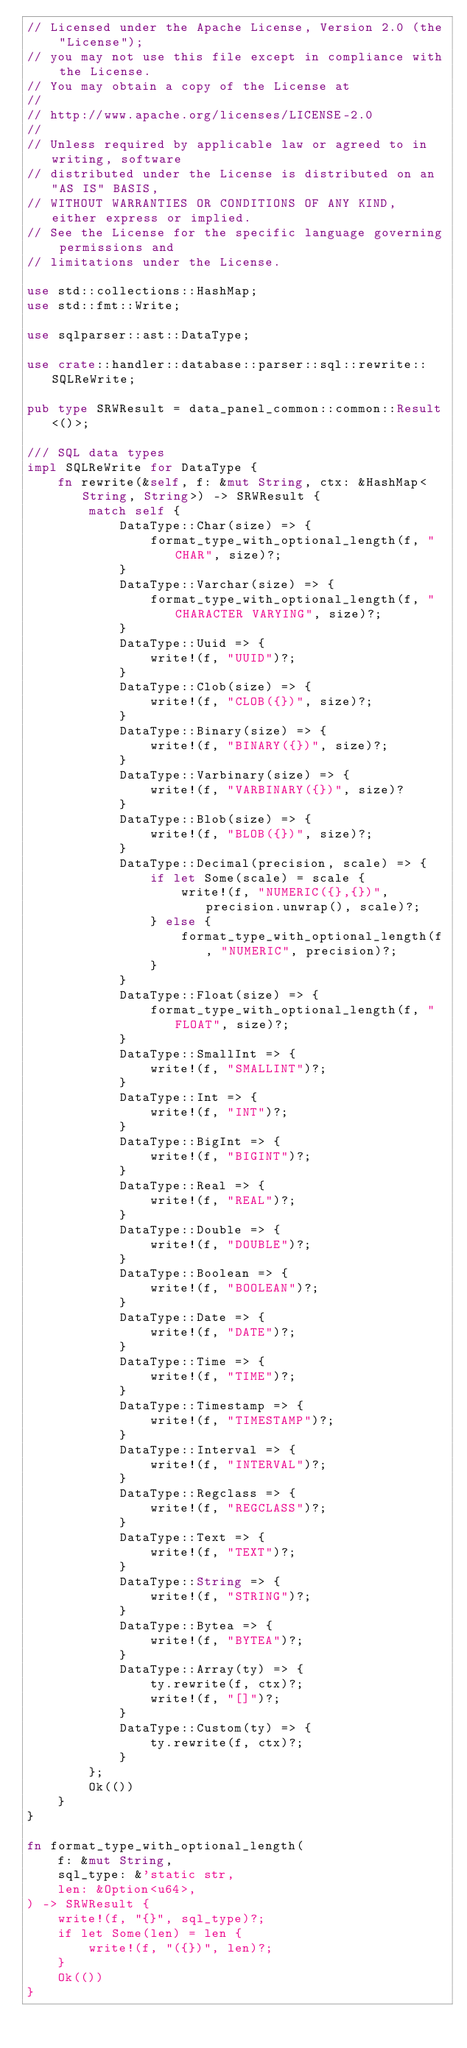<code> <loc_0><loc_0><loc_500><loc_500><_Rust_>// Licensed under the Apache License, Version 2.0 (the "License");
// you may not use this file except in compliance with the License.
// You may obtain a copy of the License at
//
// http://www.apache.org/licenses/LICENSE-2.0
//
// Unless required by applicable law or agreed to in writing, software
// distributed under the License is distributed on an "AS IS" BASIS,
// WITHOUT WARRANTIES OR CONDITIONS OF ANY KIND, either express or implied.
// See the License for the specific language governing permissions and
// limitations under the License.

use std::collections::HashMap;
use std::fmt::Write;

use sqlparser::ast::DataType;

use crate::handler::database::parser::sql::rewrite::SQLReWrite;

pub type SRWResult = data_panel_common::common::Result<()>;

/// SQL data types
impl SQLReWrite for DataType {
    fn rewrite(&self, f: &mut String, ctx: &HashMap<String, String>) -> SRWResult {
        match self {
            DataType::Char(size) => {
                format_type_with_optional_length(f, "CHAR", size)?;
            }
            DataType::Varchar(size) => {
                format_type_with_optional_length(f, "CHARACTER VARYING", size)?;
            }
            DataType::Uuid => {
                write!(f, "UUID")?;
            }
            DataType::Clob(size) => {
                write!(f, "CLOB({})", size)?;
            }
            DataType::Binary(size) => {
                write!(f, "BINARY({})", size)?;
            }
            DataType::Varbinary(size) => {
                write!(f, "VARBINARY({})", size)?
            }
            DataType::Blob(size) => {
                write!(f, "BLOB({})", size)?;
            }
            DataType::Decimal(precision, scale) => {
                if let Some(scale) = scale {
                    write!(f, "NUMERIC({},{})", precision.unwrap(), scale)?;
                } else {
                    format_type_with_optional_length(f, "NUMERIC", precision)?;
                }
            }
            DataType::Float(size) => {
                format_type_with_optional_length(f, "FLOAT", size)?;
            }
            DataType::SmallInt => {
                write!(f, "SMALLINT")?;
            }
            DataType::Int => {
                write!(f, "INT")?;
            }
            DataType::BigInt => {
                write!(f, "BIGINT")?;
            }
            DataType::Real => {
                write!(f, "REAL")?;
            }
            DataType::Double => {
                write!(f, "DOUBLE")?;
            }
            DataType::Boolean => {
                write!(f, "BOOLEAN")?;
            }
            DataType::Date => {
                write!(f, "DATE")?;
            }
            DataType::Time => {
                write!(f, "TIME")?;
            }
            DataType::Timestamp => {
                write!(f, "TIMESTAMP")?;
            }
            DataType::Interval => {
                write!(f, "INTERVAL")?;
            }
            DataType::Regclass => {
                write!(f, "REGCLASS")?;
            }
            DataType::Text => {
                write!(f, "TEXT")?;
            }
            DataType::String => {
                write!(f, "STRING")?;
            }
            DataType::Bytea => {
                write!(f, "BYTEA")?;
            }
            DataType::Array(ty) => {
                ty.rewrite(f, ctx)?;
                write!(f, "[]")?;
            }
            DataType::Custom(ty) => {
                ty.rewrite(f, ctx)?;
            }
        };
        Ok(())
    }
}

fn format_type_with_optional_length(
    f: &mut String,
    sql_type: &'static str,
    len: &Option<u64>,
) -> SRWResult {
    write!(f, "{}", sql_type)?;
    if let Some(len) = len {
        write!(f, "({})", len)?;
    }
    Ok(())
}
</code> 